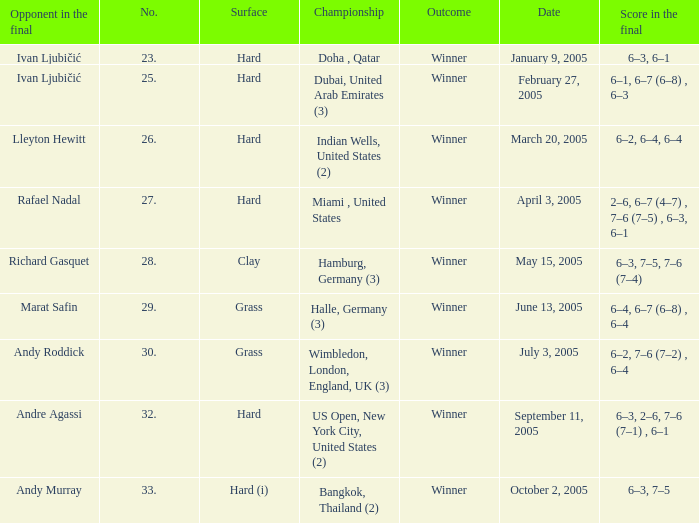Can you parse all the data within this table? {'header': ['Opponent in the final', 'No.', 'Surface', 'Championship', 'Outcome', 'Date', 'Score in the final'], 'rows': [['Ivan Ljubičić', '23.', 'Hard', 'Doha , Qatar', 'Winner', 'January 9, 2005', '6–3, 6–1'], ['Ivan Ljubičić', '25.', 'Hard', 'Dubai, United Arab Emirates (3)', 'Winner', 'February 27, 2005', '6–1, 6–7 (6–8) , 6–3'], ['Lleyton Hewitt', '26.', 'Hard', 'Indian Wells, United States (2)', 'Winner', 'March 20, 2005', '6–2, 6–4, 6–4'], ['Rafael Nadal', '27.', 'Hard', 'Miami , United States', 'Winner', 'April 3, 2005', '2–6, 6–7 (4–7) , 7–6 (7–5) , 6–3, 6–1'], ['Richard Gasquet', '28.', 'Clay', 'Hamburg, Germany (3)', 'Winner', 'May 15, 2005', '6–3, 7–5, 7–6 (7–4)'], ['Marat Safin', '29.', 'Grass', 'Halle, Germany (3)', 'Winner', 'June 13, 2005', '6–4, 6–7 (6–8) , 6–4'], ['Andy Roddick', '30.', 'Grass', 'Wimbledon, London, England, UK (3)', 'Winner', 'July 3, 2005', '6–2, 7–6 (7–2) , 6–4'], ['Andre Agassi', '32.', 'Hard', 'US Open, New York City, United States (2)', 'Winner', 'September 11, 2005', '6–3, 2–6, 7–6 (7–1) , 6–1'], ['Andy Murray', '33.', 'Hard (i)', 'Bangkok, Thailand (2)', 'Winner', 'October 2, 2005', '6–3, 7–5']]} How many championships are there on the date January 9, 2005? 1.0. 